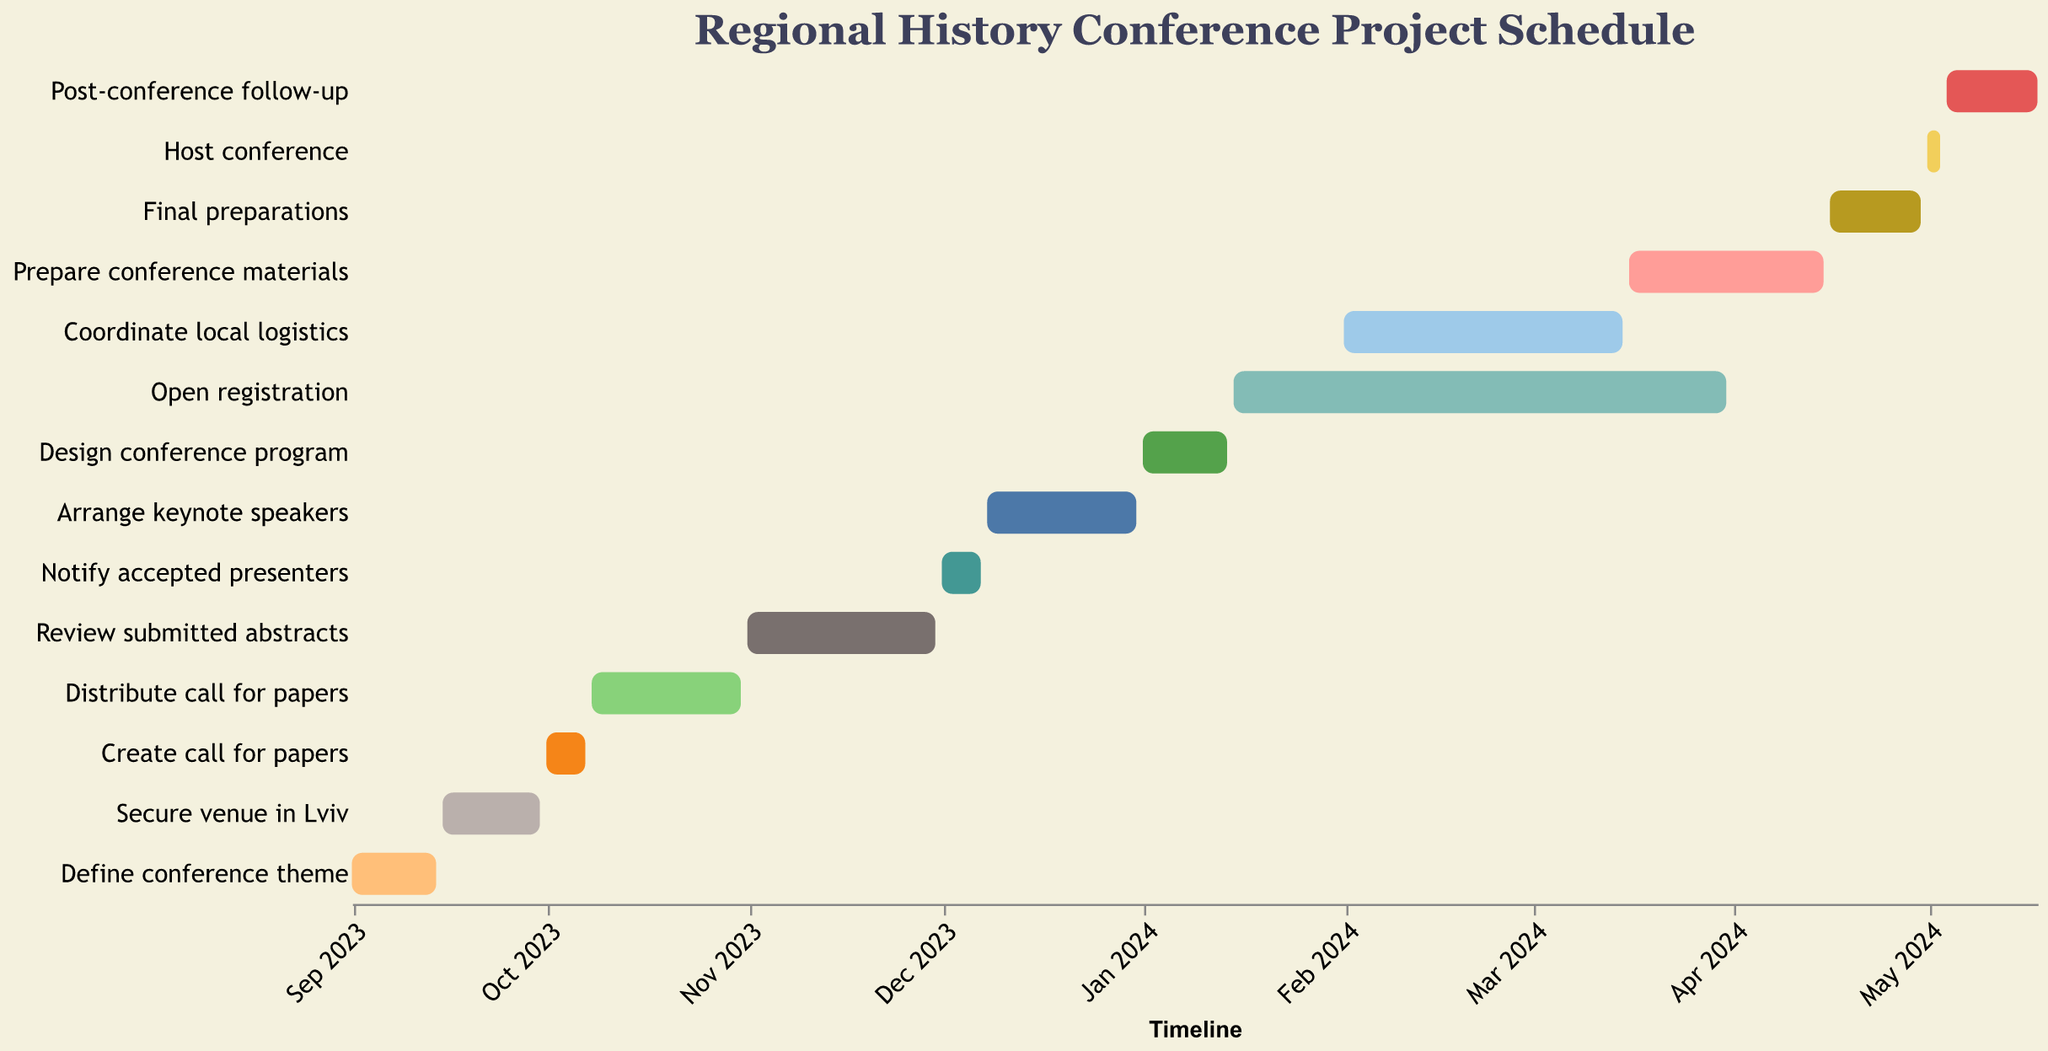What's the duration of the "Define conference theme" task? The duration is given directly in the visual information for each task. Look for "Define conference theme" and find its duration value.
Answer: 14 days What is the overall time period covered by this conference project? The project starts on 2023-09-01 and ends on 2024-05-18.
Answer: From 2023-09-01 to 2024-05-18 Which tasks occur in January 2024? Look for tasks that have start and end dates that fall within January 2024. The tasks are "Design conference program" and "Open registration".
Answer: Design conference program, Open registration How long is the "Open registration" task and how does it compare to "Prepare conference materials"? Check the durations for both tasks. "Open registration" lasts for 77 days and "Prepare conference materials" lasts for 31 days. The difference is 77 - 31 = 46 days.
Answer: 46 days longer What tasks are critical to complete before January 2024? Identify all tasks that end before 2024-01-01. These tasks include "Define conference theme", "Secure venue in Lviv", "Create call for papers", "Distribute call for papers", "Review submitted abstracts", "Notify accepted presenters", and "Arrange keynote speakers".
Answer: Define conference theme, Secure venue in Lviv, Create call for papers, Distribute call for papers, Review submitted abstracts, Notify accepted presenters, Arrange keynote speakers Is the "Coordinate local logistics" task longer or shorter than the "Prepare conference materials" task? Look at the durations for both tasks. "Coordinate local logistics" lasts for 44 days and "Prepare conference materials" lasts for 31 days.
Answer: Longer Which task follows immediately after the "Host conference"? Find the task that starts right after "Host conference" ends. The "Host conference" task ends on 2024-05-03 and the task starting on 2024-05-04 is "Post-conference follow-up".
Answer: Post-conference follow-up What is the relationship between the start date of the "Review submitted abstracts" task and the end date of the "Distribute call for papers" task? Check the end date of the "Distribute call for papers" task (2023-10-31) and compare it to the start date of "Review submitted abstracts" (2023-11-01). The "Review submitted abstracts" task starts the day after the "Distribute call for papers" task ends.
Answer: Starts the next day 